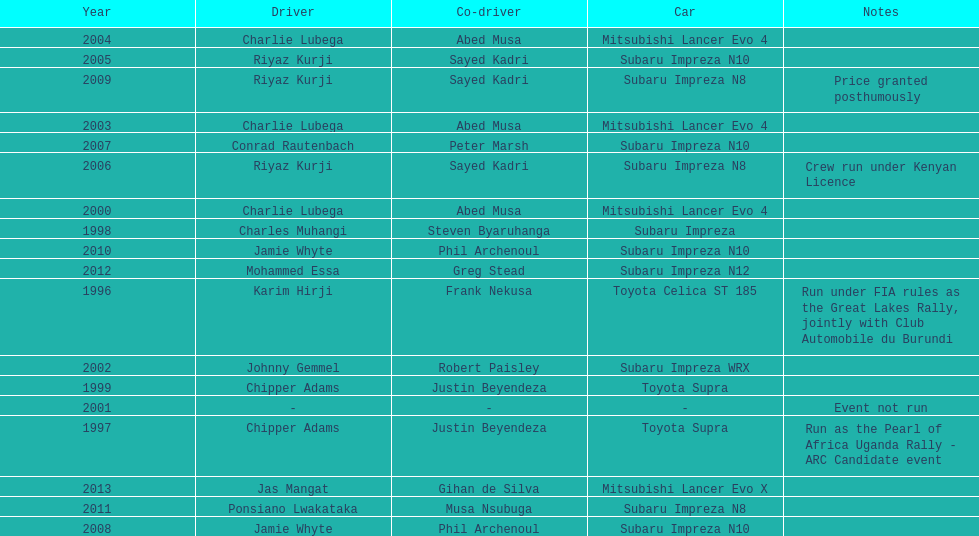Which driver won after ponsiano lwakataka? Mohammed Essa. 